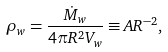<formula> <loc_0><loc_0><loc_500><loc_500>\rho _ { w } = \frac { \dot { M } _ { w } } { 4 \pi R ^ { 2 } V _ { w } } \equiv A R ^ { - 2 } ,</formula> 